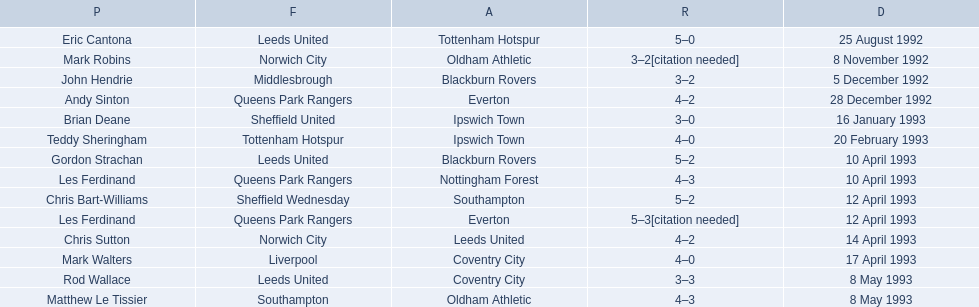What are the results? 5–0, 3–2[citation needed], 3–2, 4–2, 3–0, 4–0, 5–2, 4–3, 5–2, 5–3[citation needed], 4–2, 4–0, 3–3, 4–3. What result did mark robins have? 3–2[citation needed]. What other player had that result? John Hendrie. 